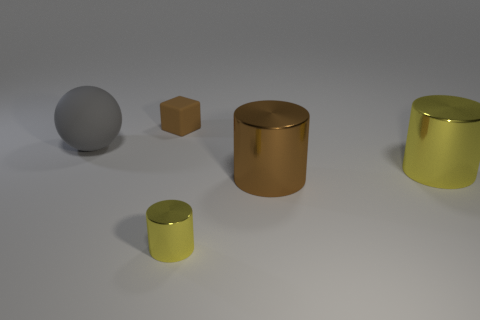Subtract all big cylinders. How many cylinders are left? 1 Add 5 big objects. How many objects exist? 10 Subtract all cylinders. How many objects are left? 2 Add 5 shiny cylinders. How many shiny cylinders are left? 8 Add 4 tiny brown things. How many tiny brown things exist? 5 Subtract 1 gray spheres. How many objects are left? 4 Subtract all brown blocks. Subtract all gray spheres. How many objects are left? 3 